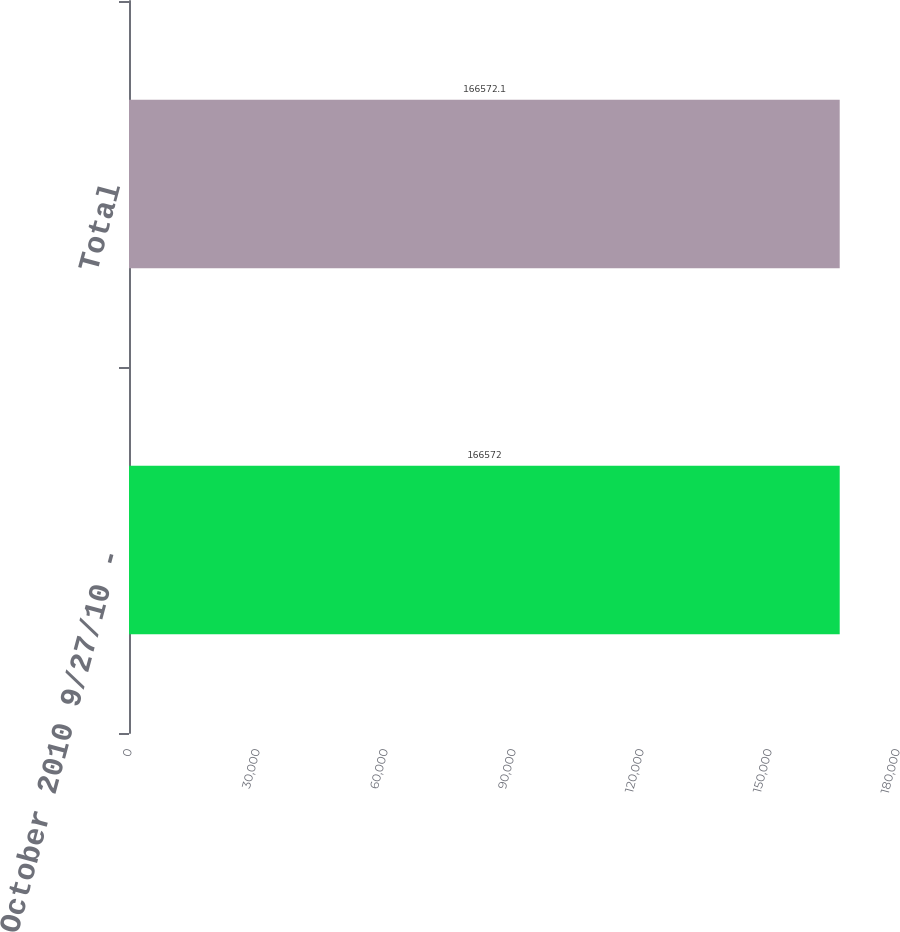Convert chart. <chart><loc_0><loc_0><loc_500><loc_500><bar_chart><fcel>October 2010 9/27/10 -<fcel>Total<nl><fcel>166572<fcel>166572<nl></chart> 